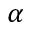Convert formula to latex. <formula><loc_0><loc_0><loc_500><loc_500>\alpha</formula> 